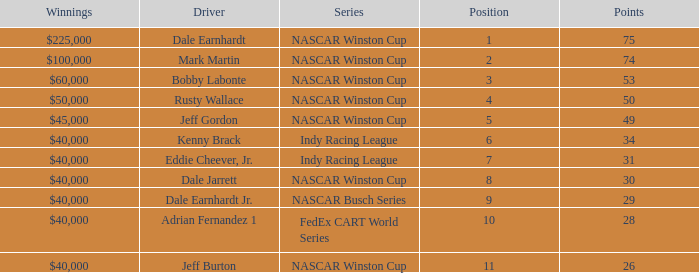How much did Kenny Brack win? $40,000. 